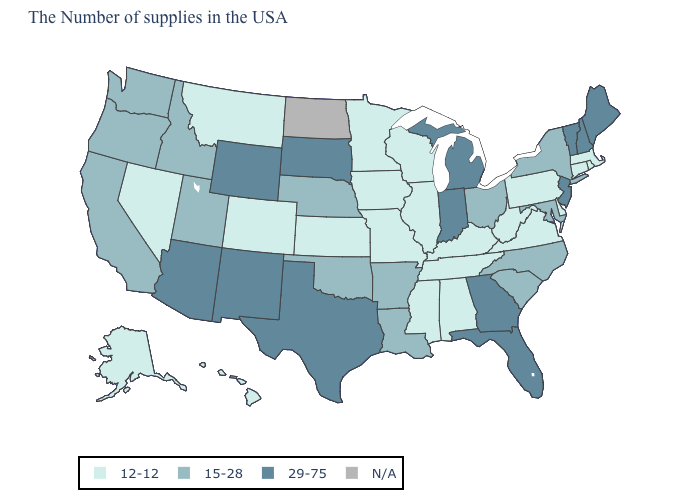Among the states that border Texas , which have the highest value?
Keep it brief. New Mexico. Is the legend a continuous bar?
Quick response, please. No. What is the value of Hawaii?
Short answer required. 12-12. Among the states that border Utah , does Idaho have the highest value?
Give a very brief answer. No. Does Louisiana have the highest value in the South?
Concise answer only. No. What is the lowest value in states that border Virginia?
Write a very short answer. 12-12. What is the value of North Dakota?
Write a very short answer. N/A. Name the states that have a value in the range 29-75?
Short answer required. Maine, New Hampshire, Vermont, New Jersey, Florida, Georgia, Michigan, Indiana, Texas, South Dakota, Wyoming, New Mexico, Arizona. What is the value of Tennessee?
Give a very brief answer. 12-12. What is the value of New York?
Answer briefly. 15-28. Does the first symbol in the legend represent the smallest category?
Keep it brief. Yes. Name the states that have a value in the range N/A?
Quick response, please. North Dakota. What is the highest value in the MidWest ?
Quick response, please. 29-75. How many symbols are there in the legend?
Quick response, please. 4. 